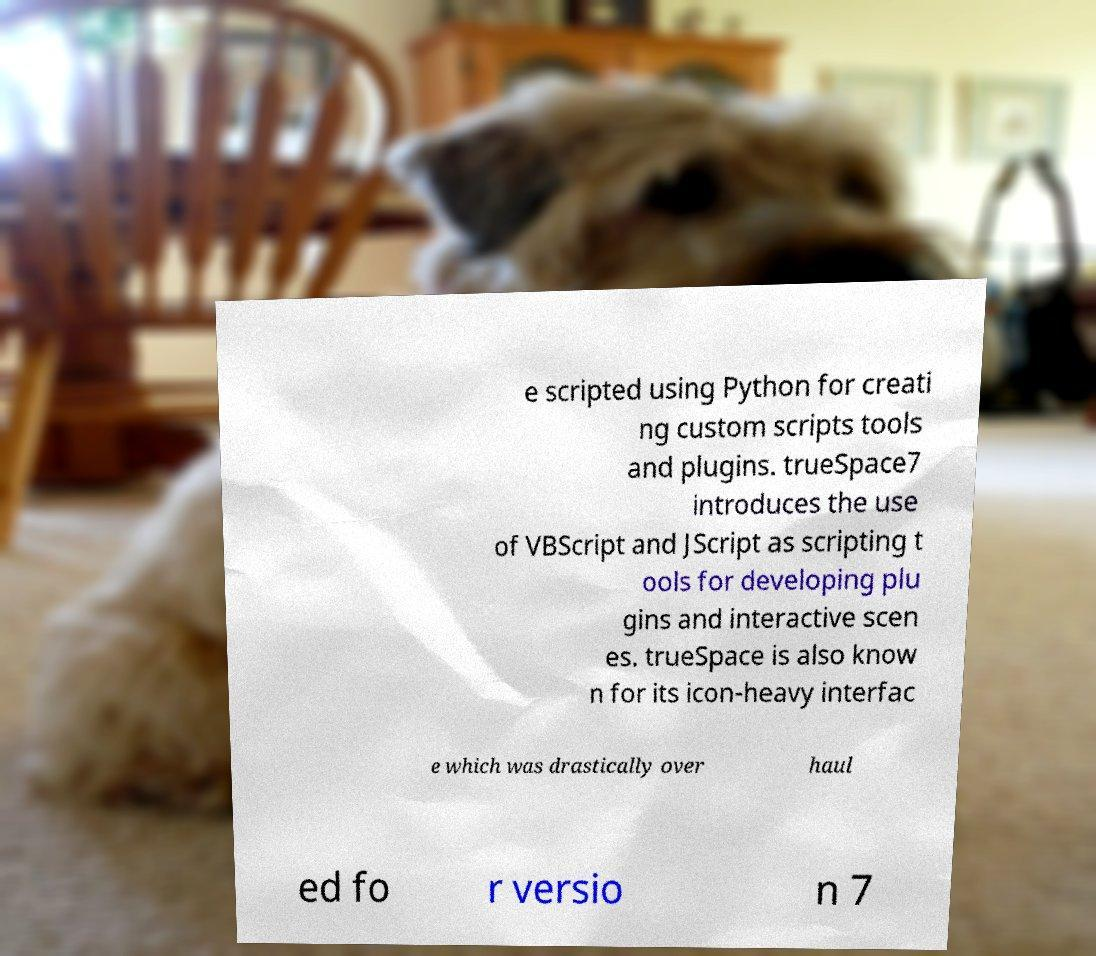What messages or text are displayed in this image? I need them in a readable, typed format. e scripted using Python for creati ng custom scripts tools and plugins. trueSpace7 introduces the use of VBScript and JScript as scripting t ools for developing plu gins and interactive scen es. trueSpace is also know n for its icon-heavy interfac e which was drastically over haul ed fo r versio n 7 